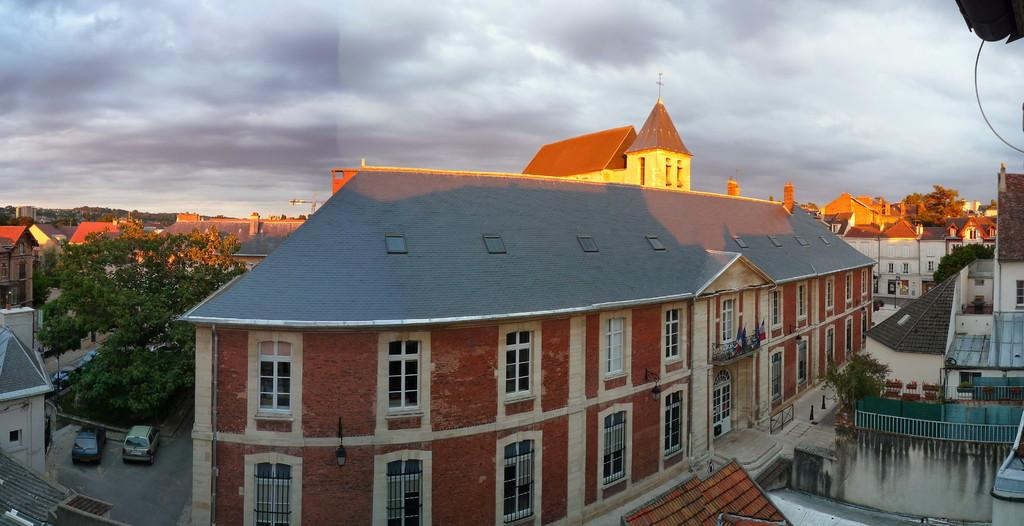What type of structures can be seen in the image? There are buildings in the image. What else can be seen in the image besides buildings? There are trees and cars on the road in the image. What is visible in the background of the image? The sky is visible in the background of the image. Can you see any letters on the buildings in the image? There is no mention of letters on the buildings in the image, so we cannot determine if any are present. 